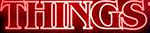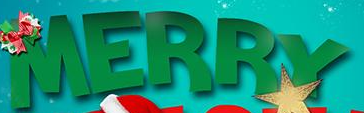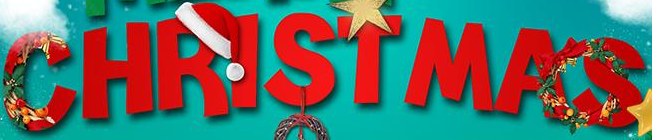Read the text from these images in sequence, separated by a semicolon. THINGS; MERRY; CHRISTMAS 